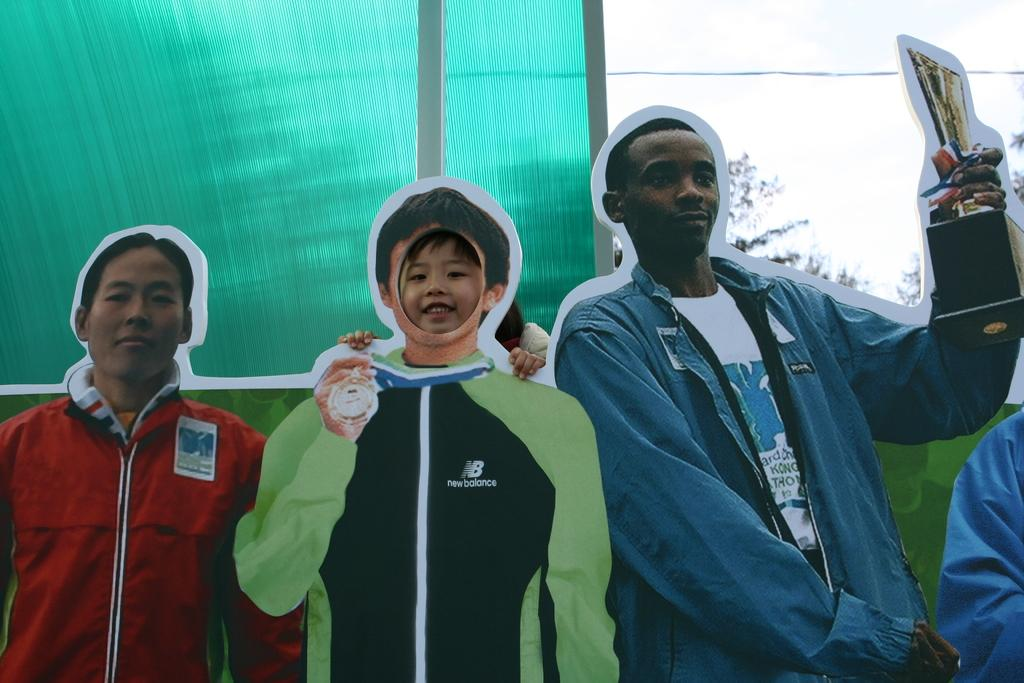What is depicted on the posters in the image? There are posters of people in the image. What color is the background behind the posters? The background behind the posters is green. What part of the sky can be seen in the image? The sky is visible in the right top corner of the image. What type of vegetation is present in the image? There are leaves in the image. How many cows are grazing in the yard in the image? There are no cows or yards present in the image; it features posters of people with a green background and leaves. What type of bulb is illuminating the posters in the image? There is no bulb present in the image; the posters are not illuminated. 